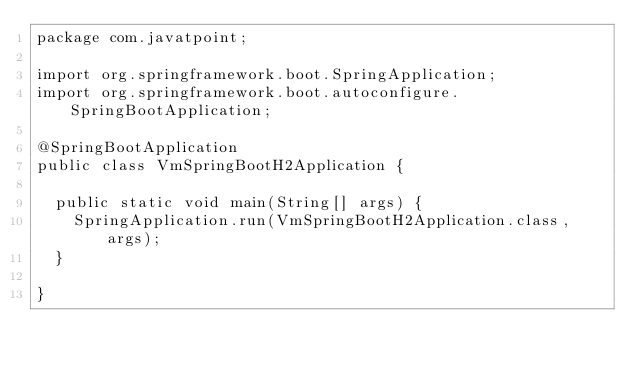<code> <loc_0><loc_0><loc_500><loc_500><_Java_>package com.javatpoint;

import org.springframework.boot.SpringApplication;
import org.springframework.boot.autoconfigure.SpringBootApplication;

@SpringBootApplication
public class VmSpringBootH2Application {

	public static void main(String[] args) {
		SpringApplication.run(VmSpringBootH2Application.class, args);
	}

}
</code> 